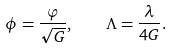Convert formula to latex. <formula><loc_0><loc_0><loc_500><loc_500>\phi = \frac { \varphi } { \sqrt { G } } , \quad \Lambda = \frac { \lambda } { 4 G } .</formula> 